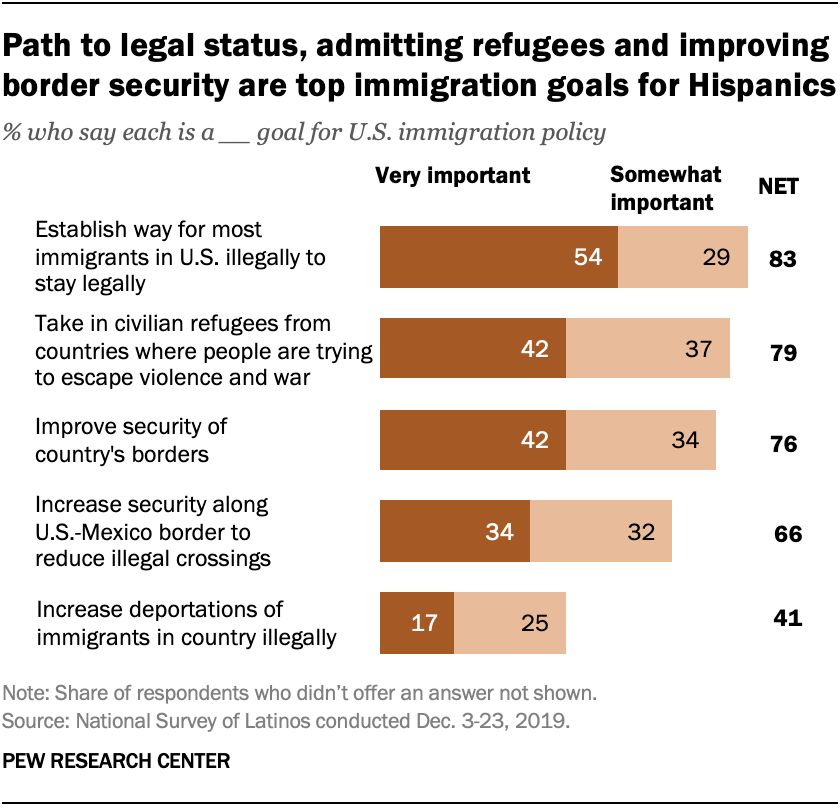List a handful of essential elements in this visual. According to the survey, 42% of respondents believe that enhancing the security of a country's borders is very important for the country's overall security. The value of individuals who prioritize improving the security of their country's borders is of great significance. 